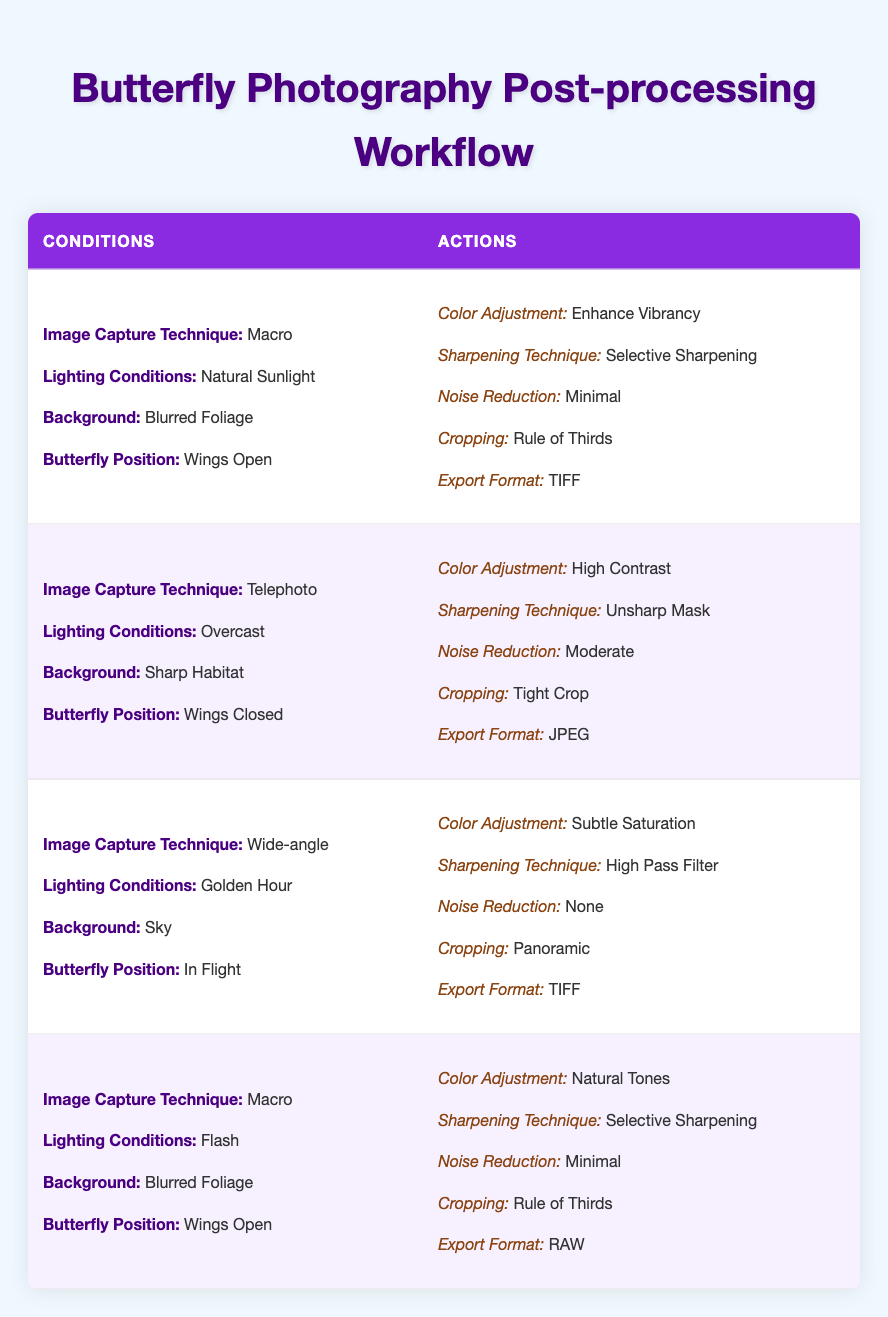What color adjustment is suggested for butterfly images captured using the macro technique in natural sunlight with wings open? The table indicates that for images taken using the macro technique in natural sunlight and with wings open, the recommended color adjustment is "Enhance Vibrancy."
Answer: Enhance Vibrancy Is "High Contrast" recommended for images captured using a telephoto lens under overcast conditions? According to the table, when images are captured using the telephoto technique in overcast conditions, the color adjustment recommended is "High Contrast." Therefore, the answer is yes, it is recommended.
Answer: Yes What noise reduction level is suggested for wide-angle images taken during the golden hour with the butterfly in flight? The table shows that for wide-angle images taken during the golden hour with the butterfly in flight, the suggested noise reduction level is "None."
Answer: None Does the table suggest that minimal noise reduction is recommended for images captured with a macro technique under flash lighting? The information reveals that for macro images taken under flash conditions, the recommended noise reduction level is "Minimal." So, the statement is true.
Answer: True What cropping style is suggested for butterfly images taken in flight with a wide-angle lens during the golden hour? The table specifies that for this scenario, the cropping style suggested is "Panoramic."
Answer: Panoramic How many different actions are recommended for macro captures in natural sunlight compared to telephoto captures in overcast conditions? For macro captures in natural sunlight, there are 5 actions (Enhance Vibrancy, Selective Sharpening, Minimal noise reduction, Rule of Thirds, TIFF). For telephoto captures in overcast conditions, there are also 5 actions (High Contrast, Unsharp Mask, Moderate noise reduction, Tight Crop, JPEG). Thus, the number of actions is the same.
Answer: 5 Which export format is suggested for macro images captured under flash lighting with wings open? The table specifies that the export format for macro images taken under flash lighting with wings open is "RAW."
Answer: RAW Which background style is suggested for telephoto images where the butterfly has its wings closed during overcast conditions? The table indicates that for telephoto images captured during overcast conditions with wings closed, the background style should be "Sharp Habitat."
Answer: Sharp Habitat If you were to compare the noise reduction recommendations for macro images under both natural sunlight and flash lighting conditions, what would they be? The table shows that for macro images in natural sunlight, the noise reduction is "Minimal," while for macro images under flash lighting, it is also "Minimal." Thus, both recommendations are the same.
Answer: Both are Minimal 